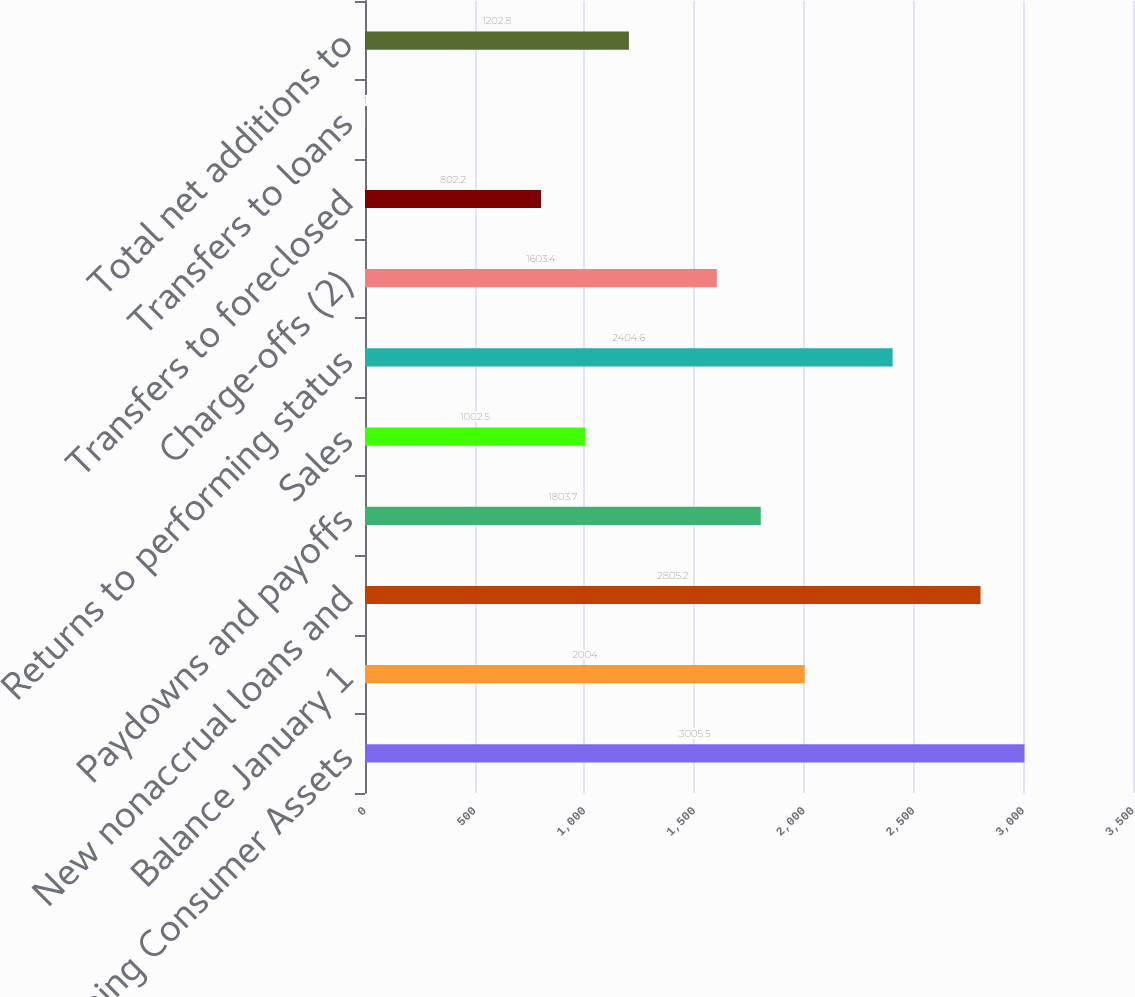Convert chart to OTSL. <chart><loc_0><loc_0><loc_500><loc_500><bar_chart><fcel>Nonperforming Consumer Assets<fcel>Balance January 1<fcel>New nonaccrual loans and<fcel>Paydowns and payoffs<fcel>Sales<fcel>Returns to performing status<fcel>Charge-offs (2)<fcel>Transfers to foreclosed<fcel>Transfers to loans<fcel>Total net additions to<nl><fcel>3005.5<fcel>2004<fcel>2805.2<fcel>1803.7<fcel>1002.5<fcel>2404.6<fcel>1603.4<fcel>802.2<fcel>1<fcel>1202.8<nl></chart> 